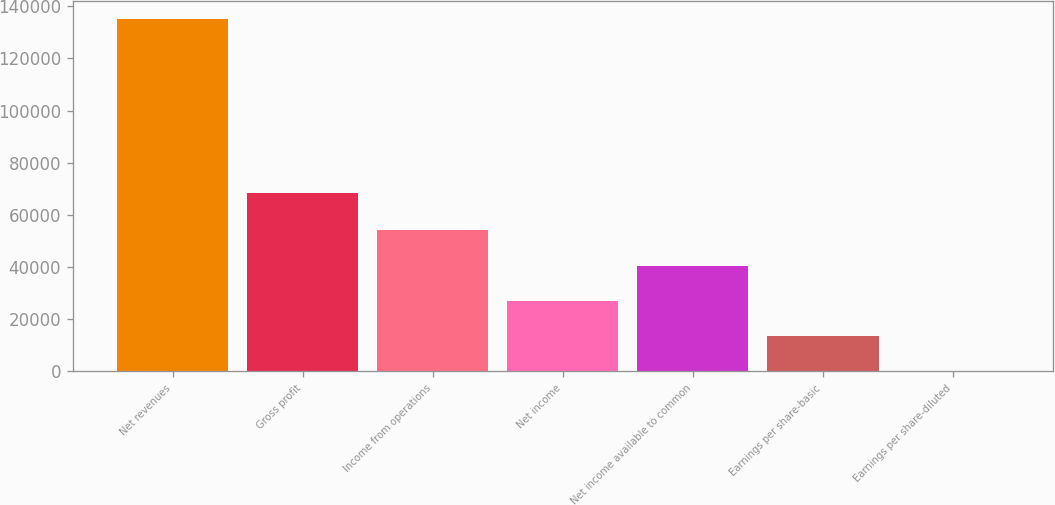<chart> <loc_0><loc_0><loc_500><loc_500><bar_chart><fcel>Net revenues<fcel>Gross profit<fcel>Income from operations<fcel>Net income<fcel>Net income available to common<fcel>Earnings per share-basic<fcel>Earnings per share-diluted<nl><fcel>135283<fcel>68406<fcel>54113.4<fcel>27056.8<fcel>40585.1<fcel>13528.5<fcel>0.24<nl></chart> 